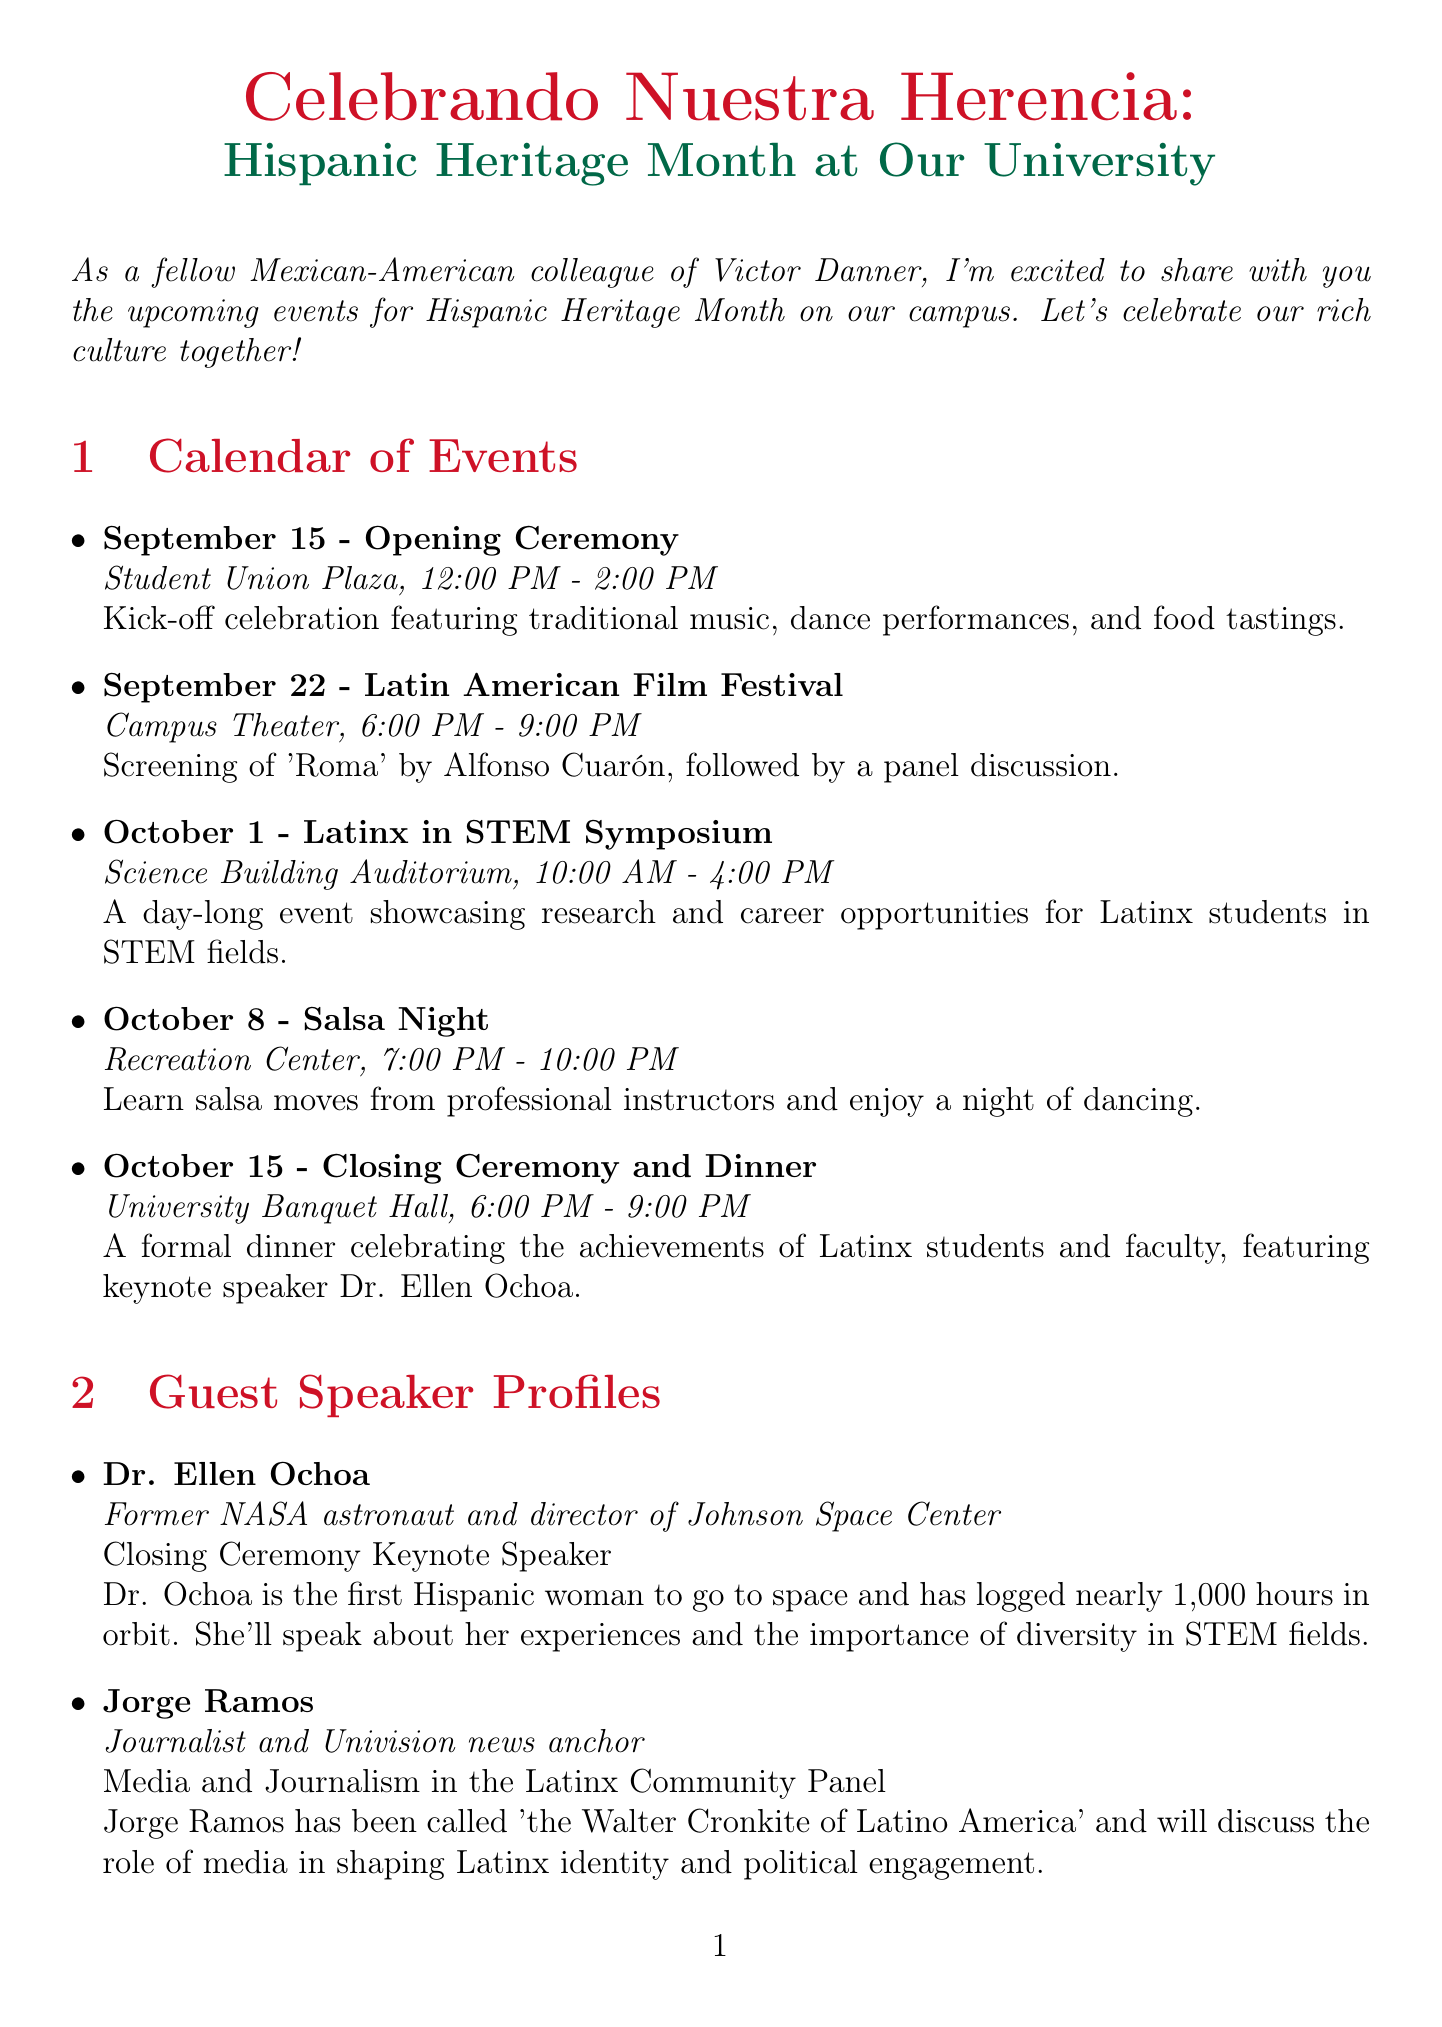What is the title of the newsletter? The title of the newsletter is provided at the beginning of the document under "newsletterTitle".
Answer: Celebrando Nuestra Herencia: Hispanic Heritage Month at Our University When is the Latin American Film Festival? The date of the Latin American Film Festival is listed in the calendar of events section.
Answer: September 22 Who is the keynote speaker for the Closing Ceremony? The keynote speaker's name is included in the guest speaker profiles section for the Closing Ceremony.
Answer: Dr. Ellen Ochoa What type of event is scheduled for October 8? The event type can be found in the calendar of events section for that date.
Answer: Salsa Night How long will the exhibit on Frida Kahlo be available? The duration of the exhibit can be found under the cultural highlight section.
Answer: September 15 - October 15 Which location will host the Latinx in STEM Symposium? The event's location is specified in the calendar of events.
Answer: Science Building Auditorium What is the focus of the Latinx Youth Mentorship Program? The aim of the mentorship program is described in detail under the community outreach section.
Answer: College applications, career planning, and cultural identity Who will lead the Culinary Arts Workshop? The leader of the workshop is specified in the guest speaker profiles section.
Answer: Chef Daniela Soto-Innes What is the starting time for the Opening Ceremony? The starting time for the Opening Ceremony is listed in the calendar of events.
Answer: 12:00 PM 